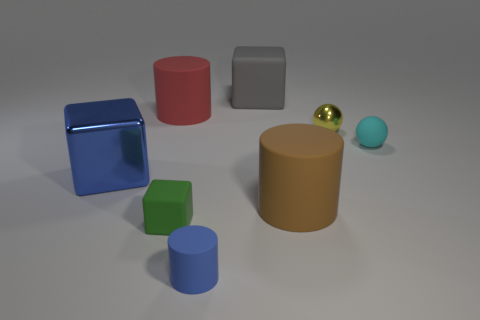Subtract all big gray matte cubes. How many cubes are left? 2 Add 1 cyan matte things. How many objects exist? 9 Subtract all cylinders. How many objects are left? 5 Subtract all yellow balls. How many balls are left? 1 Subtract 0 brown spheres. How many objects are left? 8 Subtract 3 cylinders. How many cylinders are left? 0 Subtract all blue spheres. Subtract all purple cylinders. How many spheres are left? 2 Subtract all red cubes. How many red cylinders are left? 1 Subtract all green rubber blocks. Subtract all red rubber cylinders. How many objects are left? 6 Add 8 small cubes. How many small cubes are left? 9 